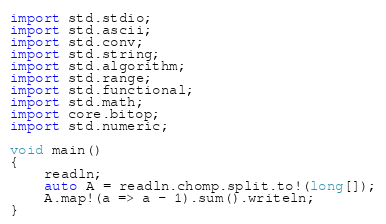<code> <loc_0><loc_0><loc_500><loc_500><_D_>import std.stdio;
import std.ascii;
import std.conv;
import std.string;
import std.algorithm;
import std.range;
import std.functional;
import std.math;
import core.bitop;
import std.numeric;

void main()
{
    readln;
    auto A = readln.chomp.split.to!(long[]);
    A.map!(a => a - 1).sum().writeln;
}
</code> 